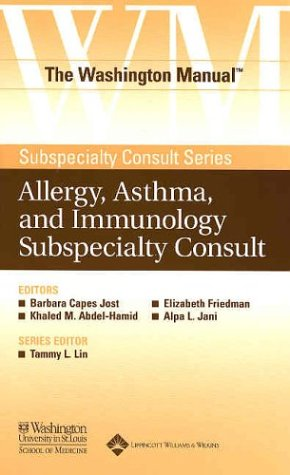What makes this manual significant in its field? This manual is part of 'The Washington Manual® Subspecialty Consult Series' known for its authoritative, concise, and practical approach. The involvement of experienced medical faculty from the Washington University School of Medicine adds significant credibility and value, making it a trusted resource in the field. 